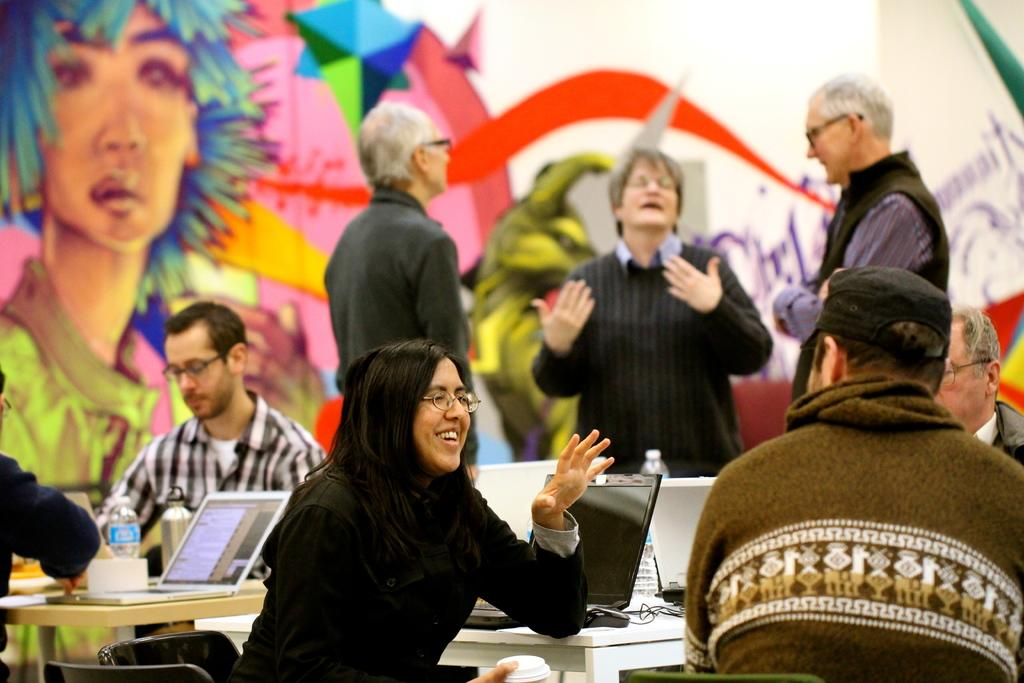How many people are sitting in chairs in the image? There are four persons sitting in chairs in the image. What is near the chairs? The chairs are near a table. What objects can be seen on the table? There is a bottle, a laptop, a mouse, and a cable on the table. Are there any other people visible in the image? Yes, there are three persons standing in the background. What type of music can be heard playing in the background of the image? There is no music present in the image; it is a still photograph. 